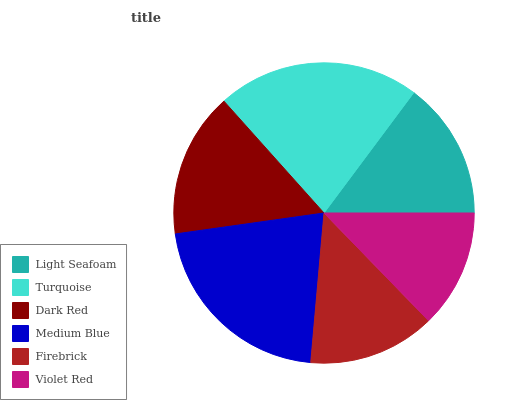Is Violet Red the minimum?
Answer yes or no. Yes. Is Turquoise the maximum?
Answer yes or no. Yes. Is Dark Red the minimum?
Answer yes or no. No. Is Dark Red the maximum?
Answer yes or no. No. Is Turquoise greater than Dark Red?
Answer yes or no. Yes. Is Dark Red less than Turquoise?
Answer yes or no. Yes. Is Dark Red greater than Turquoise?
Answer yes or no. No. Is Turquoise less than Dark Red?
Answer yes or no. No. Is Dark Red the high median?
Answer yes or no. Yes. Is Light Seafoam the low median?
Answer yes or no. Yes. Is Medium Blue the high median?
Answer yes or no. No. Is Dark Red the low median?
Answer yes or no. No. 